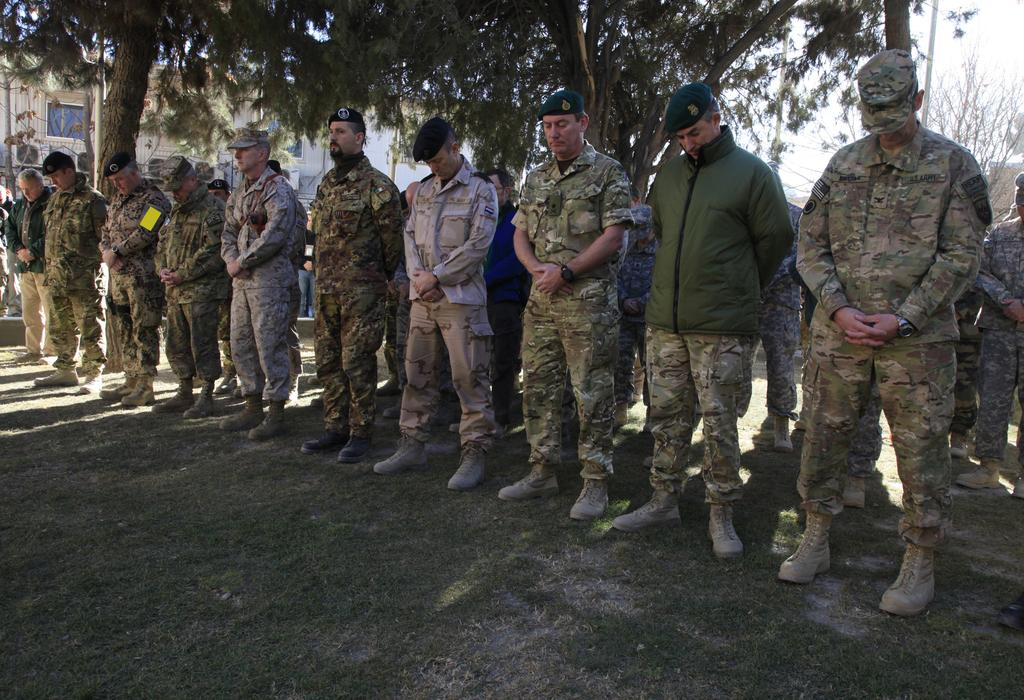How many people are visible in the image? There are many people standing in the image. What are some of the people wearing on their heads? Some of the people are wearing caps. What can be seen in the background of the image? There are trees, a building, and the sky visible in the background of the image. What type of orange object can be seen hanging from the trees in the image? There is no orange object hanging from the trees in the image; the trees are in the background and do not have any visible objects hanging from them. 